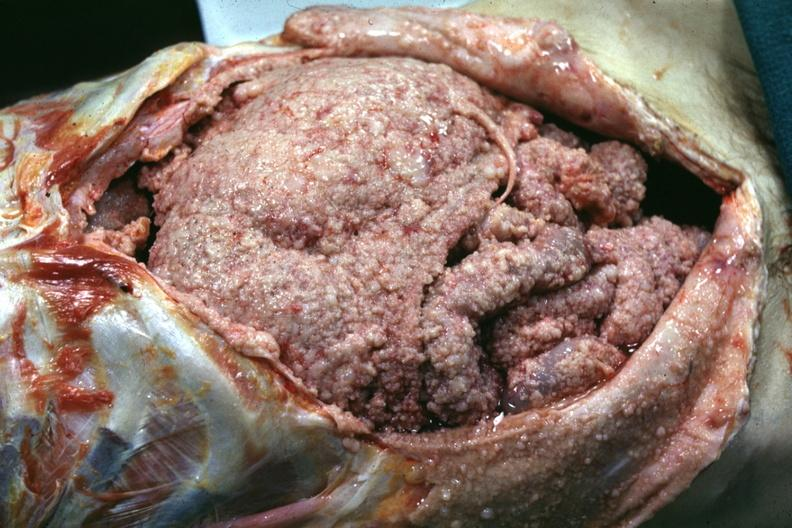s peritoneum present?
Answer the question using a single word or phrase. Yes 